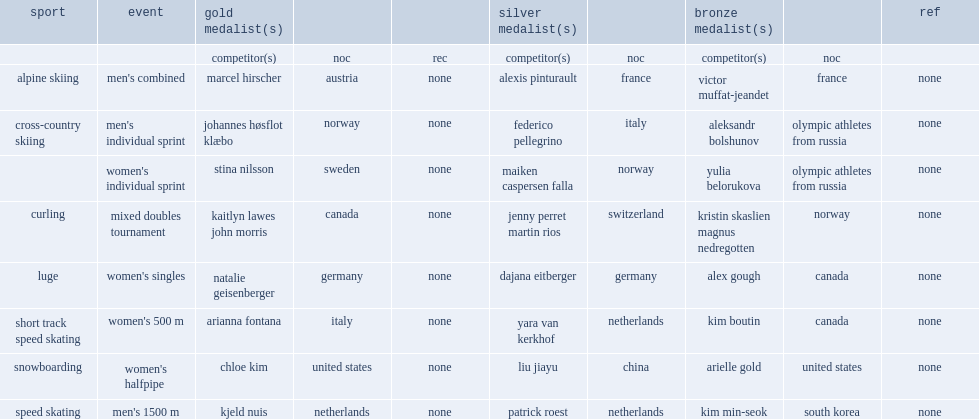Who won the snowboarding the finals of the women's halfpipe. Chloe kim. 